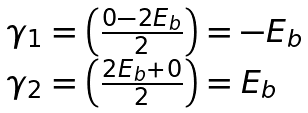Convert formula to latex. <formula><loc_0><loc_0><loc_500><loc_500>\begin{array} { l } \gamma _ { 1 } = \left ( { \frac { 0 - 2 E _ { b } } { 2 } } \right ) = - E _ { b } \\ \gamma _ { 2 } = \left ( { \frac { 2 E _ { b } + 0 } { 2 } } \right ) = E _ { b } \\ \end{array}</formula> 